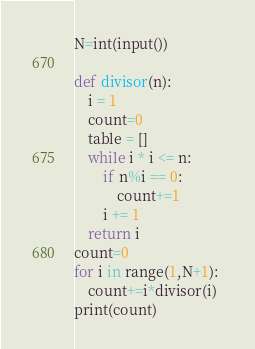Convert code to text. <code><loc_0><loc_0><loc_500><loc_500><_Python_>N=int(input())

def divisor(n): 
	i = 1
	count=0
	table = []
	while i * i <= n:
		if n%i == 0:
			count+=1
		i += 1
	return i
count=0
for i in range(1,N+1): 
	count+=i*divisor(i)
print(count)</code> 